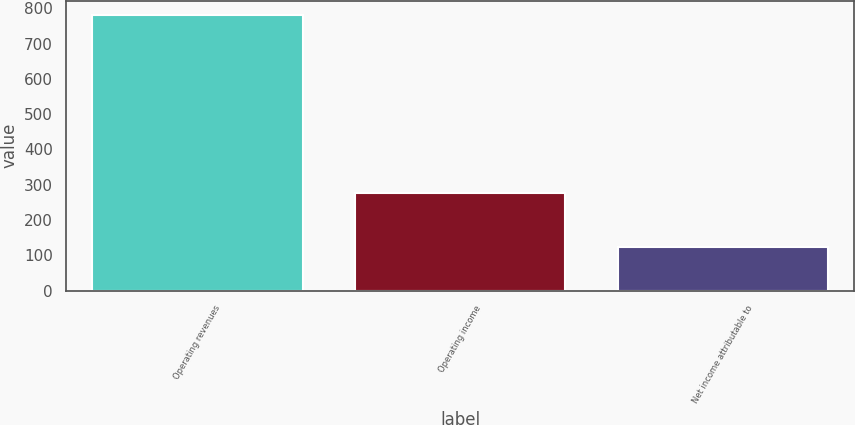Convert chart to OTSL. <chart><loc_0><loc_0><loc_500><loc_500><bar_chart><fcel>Operating revenues<fcel>Operating income<fcel>Net income attributable to<nl><fcel>782<fcel>278<fcel>123<nl></chart> 